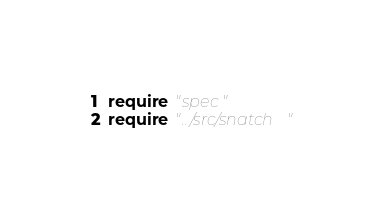Convert code to text. <code><loc_0><loc_0><loc_500><loc_500><_Crystal_>require "spec"
require "../src/snatch"
</code> 